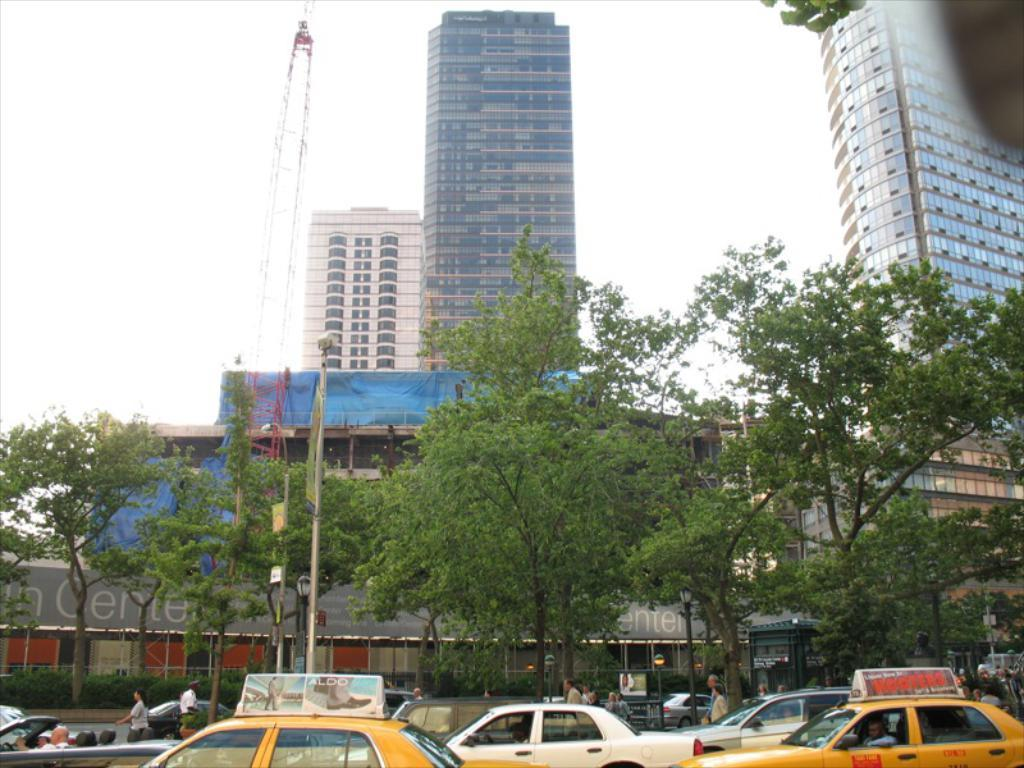<image>
Write a terse but informative summary of the picture. A busy city street is full of taxis and a building in the background that says Center. 